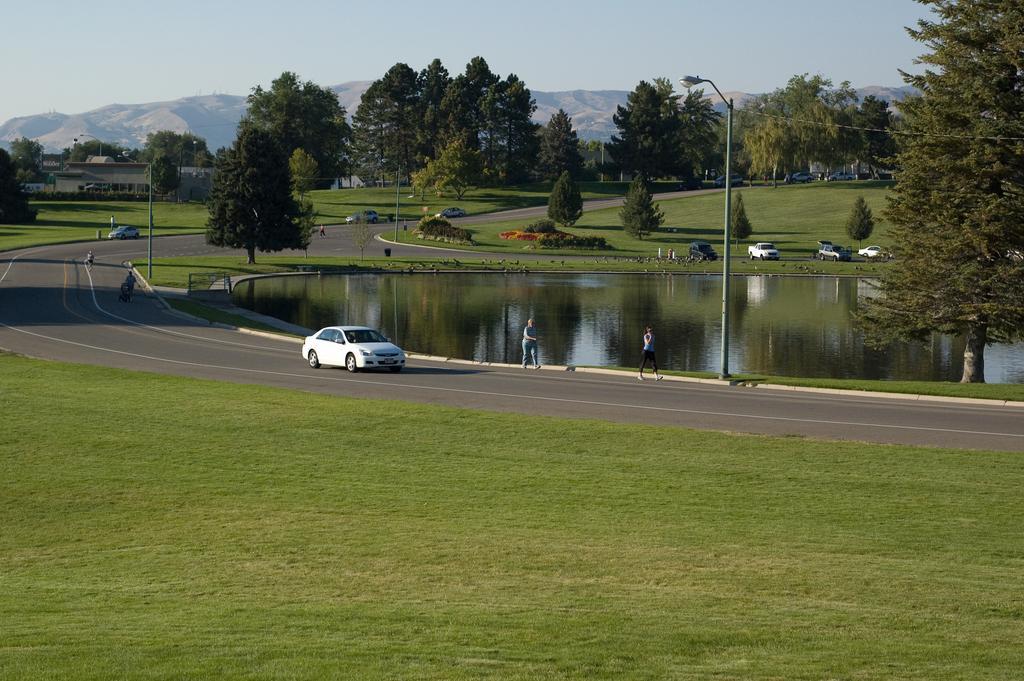Can you describe this image briefly? In the center of the image we can see cars, some persons, electric light poles, trees, grass, buildings and water. At the bottom of the image we can see ground and road. In the background of the image we can see mountains. At the top of the image there is a sky. 